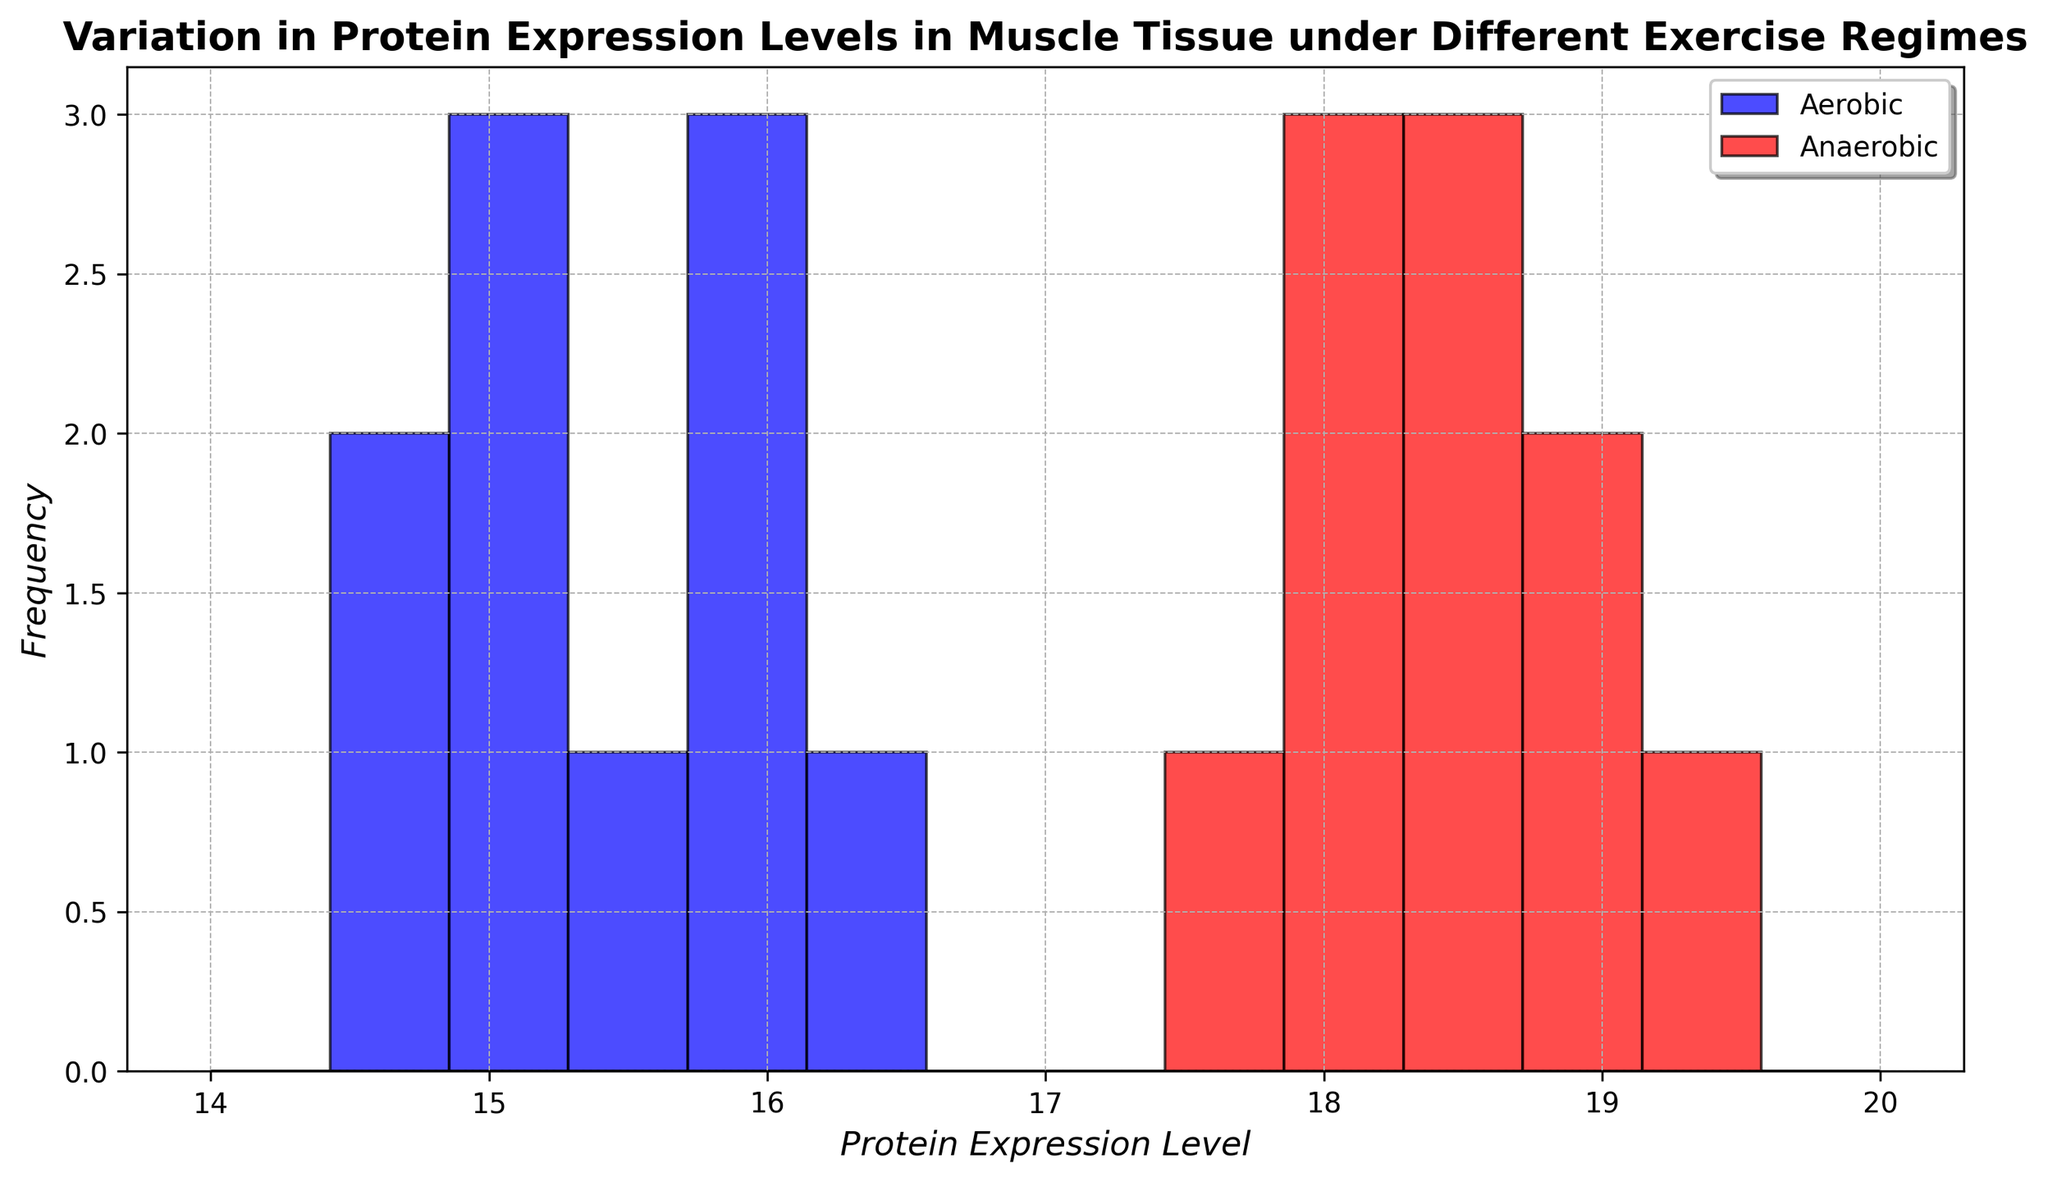What is the peak frequency for aerobic exercise? Look at the tallest bar in the blue section of the histogram; it represents the bin with the highest count.
Answer: The peak frequency is the bar between 15.0 and 15.5 Which exercise type has a higher protein expression level? Compare the central values for the red (anaerobic) and blue (aerobic) sections of the histogram. The red section is generally centered at a higher protein expression level.
Answer: Anaerobic What is the range of protein expression levels for anaerobic exercise? Identify the lowest and highest values in the red section of the histogram. The red bars start at just above 17.5 and extend to 19.2.
Answer: Approximately 17.5 to 19.2 How do the variances in protein expression levels compare between the two exercise types? Notice the width of the distributions: the aerobic section (blue) is more spread out than the anaerobic section (red).
Answer: Aerobic has a larger variance Which group has more data points in the range of 18.0 to 18.5? Count the number of bars in the range from 18.0 to 18.5 for both aerobic (blue) and anaerobic (red). Aerobic has much shorter or no bars in this range compared to anaerobic.
Answer: Anaerobic Based on the histogram, what is the median protein expression level for aerobic exercise? Find the midpoint of the blue bars' values; visually estimate the point that would split the data into two equal halves. It is around the middle of the tallest bars.
Answer: Approximately 15.1 Which exercise regime shows a more concentrated distribution? Examine which color section has bars clustered closer together. The red bars for anaerobic are more clustered compared to the blue bars for aerobic.
Answer: Anaerobic What is the average protein expression level for anaerobic exercise? Calculate the average by summing the endpoints of the highest bars in the red section and dividing by the number of bars. (For detailed steps, use values like 18.4, 17.9, etc.)
Answer: Approximately 18.3 What is the difference between the means of the two exercise types? Subtract the average of the blue histogram (aerobic) from the average of the red histogram (anaerobic). Using close approximations: Anaerobic mean is around 18.3, and aerobic mean is around 15.2.
Answer: Approximately 3.1 